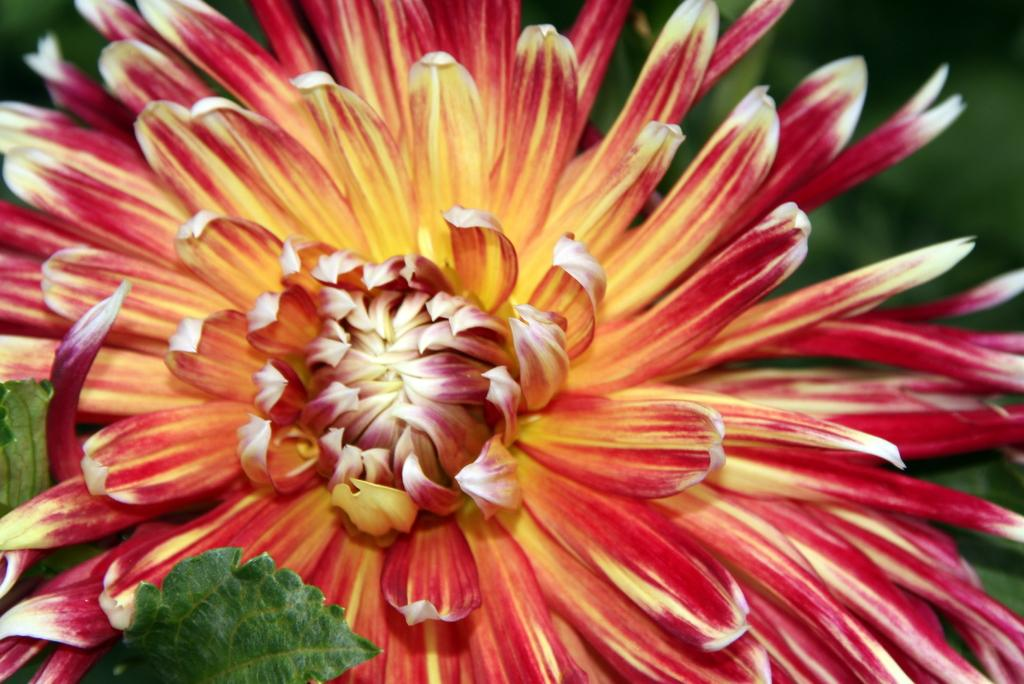What type of plant can be seen in the image? There is a flower in the image. What else is present on the plant besides the flower? There are leaves in the image. Are there any fairies visible near the flower in the image? No, there are no fairies present in the image. Can you tell me how many times the flower has been crushed in the image? The flower has not been crushed in the image; it is intact. 